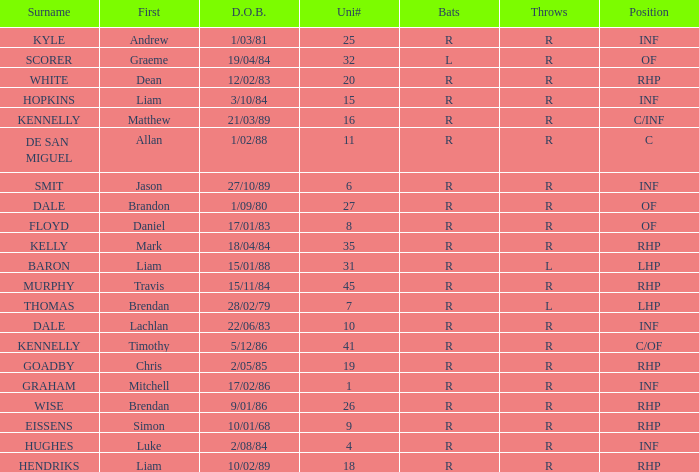Which batter has the last name Graham? R. Could you parse the entire table? {'header': ['Surname', 'First', 'D.O.B.', 'Uni#', 'Bats', 'Throws', 'Position'], 'rows': [['KYLE', 'Andrew', '1/03/81', '25', 'R', 'R', 'INF'], ['SCORER', 'Graeme', '19/04/84', '32', 'L', 'R', 'OF'], ['WHITE', 'Dean', '12/02/83', '20', 'R', 'R', 'RHP'], ['HOPKINS', 'Liam', '3/10/84', '15', 'R', 'R', 'INF'], ['KENNELLY', 'Matthew', '21/03/89', '16', 'R', 'R', 'C/INF'], ['DE SAN MIGUEL', 'Allan', '1/02/88', '11', 'R', 'R', 'C'], ['SMIT', 'Jason', '27/10/89', '6', 'R', 'R', 'INF'], ['DALE', 'Brandon', '1/09/80', '27', 'R', 'R', 'OF'], ['FLOYD', 'Daniel', '17/01/83', '8', 'R', 'R', 'OF'], ['KELLY', 'Mark', '18/04/84', '35', 'R', 'R', 'RHP'], ['BARON', 'Liam', '15/01/88', '31', 'R', 'L', 'LHP'], ['MURPHY', 'Travis', '15/11/84', '45', 'R', 'R', 'RHP'], ['THOMAS', 'Brendan', '28/02/79', '7', 'R', 'L', 'LHP'], ['DALE', 'Lachlan', '22/06/83', '10', 'R', 'R', 'INF'], ['KENNELLY', 'Timothy', '5/12/86', '41', 'R', 'R', 'C/OF'], ['GOADBY', 'Chris', '2/05/85', '19', 'R', 'R', 'RHP'], ['GRAHAM', 'Mitchell', '17/02/86', '1', 'R', 'R', 'INF'], ['WISE', 'Brendan', '9/01/86', '26', 'R', 'R', 'RHP'], ['EISSENS', 'Simon', '10/01/68', '9', 'R', 'R', 'RHP'], ['HUGHES', 'Luke', '2/08/84', '4', 'R', 'R', 'INF'], ['HENDRIKS', 'Liam', '10/02/89', '18', 'R', 'R', 'RHP']]} 